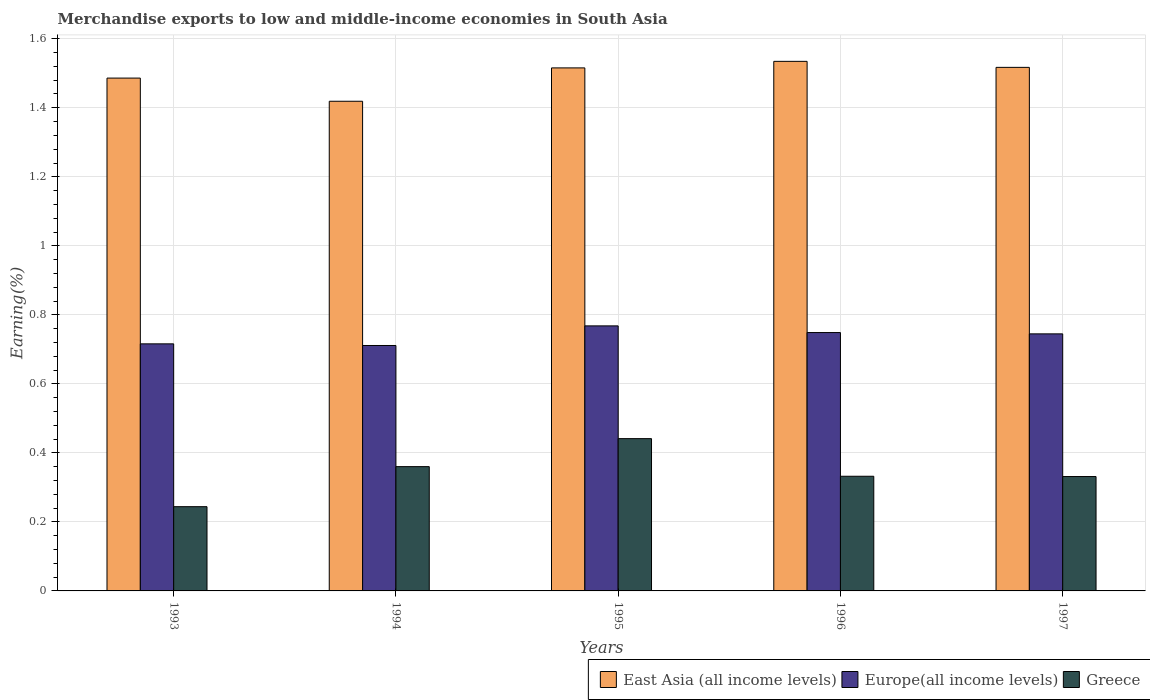How many different coloured bars are there?
Provide a short and direct response. 3. How many groups of bars are there?
Provide a succinct answer. 5. How many bars are there on the 1st tick from the left?
Give a very brief answer. 3. How many bars are there on the 4th tick from the right?
Provide a short and direct response. 3. What is the label of the 1st group of bars from the left?
Offer a terse response. 1993. In how many cases, is the number of bars for a given year not equal to the number of legend labels?
Provide a succinct answer. 0. What is the percentage of amount earned from merchandise exports in Greece in 1996?
Ensure brevity in your answer.  0.33. Across all years, what is the maximum percentage of amount earned from merchandise exports in Europe(all income levels)?
Give a very brief answer. 0.77. Across all years, what is the minimum percentage of amount earned from merchandise exports in Greece?
Give a very brief answer. 0.24. In which year was the percentage of amount earned from merchandise exports in East Asia (all income levels) maximum?
Provide a short and direct response. 1996. What is the total percentage of amount earned from merchandise exports in Greece in the graph?
Ensure brevity in your answer.  1.71. What is the difference between the percentage of amount earned from merchandise exports in Greece in 1995 and that in 1996?
Your answer should be very brief. 0.11. What is the difference between the percentage of amount earned from merchandise exports in Europe(all income levels) in 1993 and the percentage of amount earned from merchandise exports in Greece in 1995?
Provide a succinct answer. 0.27. What is the average percentage of amount earned from merchandise exports in Europe(all income levels) per year?
Ensure brevity in your answer.  0.74. In the year 1994, what is the difference between the percentage of amount earned from merchandise exports in East Asia (all income levels) and percentage of amount earned from merchandise exports in Greece?
Your response must be concise. 1.06. What is the ratio of the percentage of amount earned from merchandise exports in Greece in 1993 to that in 1994?
Provide a short and direct response. 0.68. What is the difference between the highest and the second highest percentage of amount earned from merchandise exports in Europe(all income levels)?
Ensure brevity in your answer.  0.02. What is the difference between the highest and the lowest percentage of amount earned from merchandise exports in Greece?
Make the answer very short. 0.2. In how many years, is the percentage of amount earned from merchandise exports in East Asia (all income levels) greater than the average percentage of amount earned from merchandise exports in East Asia (all income levels) taken over all years?
Provide a short and direct response. 3. What does the 2nd bar from the left in 1994 represents?
Offer a very short reply. Europe(all income levels). What does the 3rd bar from the right in 1994 represents?
Your response must be concise. East Asia (all income levels). Is it the case that in every year, the sum of the percentage of amount earned from merchandise exports in East Asia (all income levels) and percentage of amount earned from merchandise exports in Europe(all income levels) is greater than the percentage of amount earned from merchandise exports in Greece?
Provide a short and direct response. Yes. How many bars are there?
Make the answer very short. 15. How many years are there in the graph?
Your response must be concise. 5. What is the difference between two consecutive major ticks on the Y-axis?
Provide a short and direct response. 0.2. Are the values on the major ticks of Y-axis written in scientific E-notation?
Ensure brevity in your answer.  No. Does the graph contain any zero values?
Offer a terse response. No. Does the graph contain grids?
Provide a succinct answer. Yes. Where does the legend appear in the graph?
Your response must be concise. Bottom right. How many legend labels are there?
Ensure brevity in your answer.  3. How are the legend labels stacked?
Offer a terse response. Horizontal. What is the title of the graph?
Provide a succinct answer. Merchandise exports to low and middle-income economies in South Asia. What is the label or title of the Y-axis?
Offer a very short reply. Earning(%). What is the Earning(%) in East Asia (all income levels) in 1993?
Your answer should be compact. 1.49. What is the Earning(%) in Europe(all income levels) in 1993?
Offer a very short reply. 0.72. What is the Earning(%) of Greece in 1993?
Your answer should be very brief. 0.24. What is the Earning(%) in East Asia (all income levels) in 1994?
Offer a terse response. 1.42. What is the Earning(%) of Europe(all income levels) in 1994?
Ensure brevity in your answer.  0.71. What is the Earning(%) in Greece in 1994?
Offer a terse response. 0.36. What is the Earning(%) of East Asia (all income levels) in 1995?
Offer a very short reply. 1.52. What is the Earning(%) of Europe(all income levels) in 1995?
Your response must be concise. 0.77. What is the Earning(%) in Greece in 1995?
Your answer should be very brief. 0.44. What is the Earning(%) of East Asia (all income levels) in 1996?
Offer a very short reply. 1.53. What is the Earning(%) of Europe(all income levels) in 1996?
Your answer should be compact. 0.75. What is the Earning(%) of Greece in 1996?
Your response must be concise. 0.33. What is the Earning(%) in East Asia (all income levels) in 1997?
Your response must be concise. 1.52. What is the Earning(%) of Europe(all income levels) in 1997?
Make the answer very short. 0.74. What is the Earning(%) in Greece in 1997?
Give a very brief answer. 0.33. Across all years, what is the maximum Earning(%) in East Asia (all income levels)?
Offer a very short reply. 1.53. Across all years, what is the maximum Earning(%) in Europe(all income levels)?
Make the answer very short. 0.77. Across all years, what is the maximum Earning(%) in Greece?
Your answer should be very brief. 0.44. Across all years, what is the minimum Earning(%) of East Asia (all income levels)?
Provide a short and direct response. 1.42. Across all years, what is the minimum Earning(%) in Europe(all income levels)?
Provide a short and direct response. 0.71. Across all years, what is the minimum Earning(%) of Greece?
Give a very brief answer. 0.24. What is the total Earning(%) in East Asia (all income levels) in the graph?
Keep it short and to the point. 7.47. What is the total Earning(%) of Europe(all income levels) in the graph?
Keep it short and to the point. 3.69. What is the total Earning(%) of Greece in the graph?
Your response must be concise. 1.71. What is the difference between the Earning(%) in East Asia (all income levels) in 1993 and that in 1994?
Your response must be concise. 0.07. What is the difference between the Earning(%) of Europe(all income levels) in 1993 and that in 1994?
Offer a terse response. 0. What is the difference between the Earning(%) in Greece in 1993 and that in 1994?
Offer a terse response. -0.12. What is the difference between the Earning(%) of East Asia (all income levels) in 1993 and that in 1995?
Offer a very short reply. -0.03. What is the difference between the Earning(%) in Europe(all income levels) in 1993 and that in 1995?
Your answer should be very brief. -0.05. What is the difference between the Earning(%) in Greece in 1993 and that in 1995?
Keep it short and to the point. -0.2. What is the difference between the Earning(%) in East Asia (all income levels) in 1993 and that in 1996?
Provide a short and direct response. -0.05. What is the difference between the Earning(%) in Europe(all income levels) in 1993 and that in 1996?
Your answer should be compact. -0.03. What is the difference between the Earning(%) in Greece in 1993 and that in 1996?
Give a very brief answer. -0.09. What is the difference between the Earning(%) of East Asia (all income levels) in 1993 and that in 1997?
Make the answer very short. -0.03. What is the difference between the Earning(%) in Europe(all income levels) in 1993 and that in 1997?
Offer a terse response. -0.03. What is the difference between the Earning(%) in Greece in 1993 and that in 1997?
Ensure brevity in your answer.  -0.09. What is the difference between the Earning(%) of East Asia (all income levels) in 1994 and that in 1995?
Your answer should be very brief. -0.1. What is the difference between the Earning(%) of Europe(all income levels) in 1994 and that in 1995?
Ensure brevity in your answer.  -0.06. What is the difference between the Earning(%) of Greece in 1994 and that in 1995?
Your response must be concise. -0.08. What is the difference between the Earning(%) of East Asia (all income levels) in 1994 and that in 1996?
Give a very brief answer. -0.12. What is the difference between the Earning(%) of Europe(all income levels) in 1994 and that in 1996?
Ensure brevity in your answer.  -0.04. What is the difference between the Earning(%) in Greece in 1994 and that in 1996?
Make the answer very short. 0.03. What is the difference between the Earning(%) in East Asia (all income levels) in 1994 and that in 1997?
Your answer should be compact. -0.1. What is the difference between the Earning(%) of Europe(all income levels) in 1994 and that in 1997?
Your answer should be very brief. -0.03. What is the difference between the Earning(%) of Greece in 1994 and that in 1997?
Keep it short and to the point. 0.03. What is the difference between the Earning(%) of East Asia (all income levels) in 1995 and that in 1996?
Ensure brevity in your answer.  -0.02. What is the difference between the Earning(%) of Europe(all income levels) in 1995 and that in 1996?
Ensure brevity in your answer.  0.02. What is the difference between the Earning(%) of Greece in 1995 and that in 1996?
Keep it short and to the point. 0.11. What is the difference between the Earning(%) in East Asia (all income levels) in 1995 and that in 1997?
Give a very brief answer. -0. What is the difference between the Earning(%) in Europe(all income levels) in 1995 and that in 1997?
Make the answer very short. 0.02. What is the difference between the Earning(%) of Greece in 1995 and that in 1997?
Ensure brevity in your answer.  0.11. What is the difference between the Earning(%) of East Asia (all income levels) in 1996 and that in 1997?
Ensure brevity in your answer.  0.02. What is the difference between the Earning(%) of Europe(all income levels) in 1996 and that in 1997?
Give a very brief answer. 0. What is the difference between the Earning(%) of Greece in 1996 and that in 1997?
Ensure brevity in your answer.  0. What is the difference between the Earning(%) of East Asia (all income levels) in 1993 and the Earning(%) of Europe(all income levels) in 1994?
Provide a succinct answer. 0.77. What is the difference between the Earning(%) of East Asia (all income levels) in 1993 and the Earning(%) of Greece in 1994?
Keep it short and to the point. 1.13. What is the difference between the Earning(%) in Europe(all income levels) in 1993 and the Earning(%) in Greece in 1994?
Make the answer very short. 0.36. What is the difference between the Earning(%) of East Asia (all income levels) in 1993 and the Earning(%) of Europe(all income levels) in 1995?
Provide a short and direct response. 0.72. What is the difference between the Earning(%) in East Asia (all income levels) in 1993 and the Earning(%) in Greece in 1995?
Your answer should be very brief. 1.04. What is the difference between the Earning(%) in Europe(all income levels) in 1993 and the Earning(%) in Greece in 1995?
Your answer should be very brief. 0.27. What is the difference between the Earning(%) of East Asia (all income levels) in 1993 and the Earning(%) of Europe(all income levels) in 1996?
Offer a very short reply. 0.74. What is the difference between the Earning(%) in East Asia (all income levels) in 1993 and the Earning(%) in Greece in 1996?
Your response must be concise. 1.15. What is the difference between the Earning(%) in Europe(all income levels) in 1993 and the Earning(%) in Greece in 1996?
Your response must be concise. 0.38. What is the difference between the Earning(%) of East Asia (all income levels) in 1993 and the Earning(%) of Europe(all income levels) in 1997?
Your response must be concise. 0.74. What is the difference between the Earning(%) of East Asia (all income levels) in 1993 and the Earning(%) of Greece in 1997?
Keep it short and to the point. 1.15. What is the difference between the Earning(%) of Europe(all income levels) in 1993 and the Earning(%) of Greece in 1997?
Your answer should be very brief. 0.38. What is the difference between the Earning(%) in East Asia (all income levels) in 1994 and the Earning(%) in Europe(all income levels) in 1995?
Offer a very short reply. 0.65. What is the difference between the Earning(%) of East Asia (all income levels) in 1994 and the Earning(%) of Greece in 1995?
Offer a very short reply. 0.98. What is the difference between the Earning(%) in Europe(all income levels) in 1994 and the Earning(%) in Greece in 1995?
Ensure brevity in your answer.  0.27. What is the difference between the Earning(%) in East Asia (all income levels) in 1994 and the Earning(%) in Europe(all income levels) in 1996?
Provide a short and direct response. 0.67. What is the difference between the Earning(%) in East Asia (all income levels) in 1994 and the Earning(%) in Greece in 1996?
Offer a very short reply. 1.09. What is the difference between the Earning(%) of Europe(all income levels) in 1994 and the Earning(%) of Greece in 1996?
Your answer should be very brief. 0.38. What is the difference between the Earning(%) of East Asia (all income levels) in 1994 and the Earning(%) of Europe(all income levels) in 1997?
Keep it short and to the point. 0.67. What is the difference between the Earning(%) in East Asia (all income levels) in 1994 and the Earning(%) in Greece in 1997?
Your response must be concise. 1.09. What is the difference between the Earning(%) in Europe(all income levels) in 1994 and the Earning(%) in Greece in 1997?
Ensure brevity in your answer.  0.38. What is the difference between the Earning(%) of East Asia (all income levels) in 1995 and the Earning(%) of Europe(all income levels) in 1996?
Your response must be concise. 0.77. What is the difference between the Earning(%) in East Asia (all income levels) in 1995 and the Earning(%) in Greece in 1996?
Provide a succinct answer. 1.18. What is the difference between the Earning(%) of Europe(all income levels) in 1995 and the Earning(%) of Greece in 1996?
Your response must be concise. 0.44. What is the difference between the Earning(%) of East Asia (all income levels) in 1995 and the Earning(%) of Europe(all income levels) in 1997?
Provide a succinct answer. 0.77. What is the difference between the Earning(%) in East Asia (all income levels) in 1995 and the Earning(%) in Greece in 1997?
Give a very brief answer. 1.18. What is the difference between the Earning(%) in Europe(all income levels) in 1995 and the Earning(%) in Greece in 1997?
Offer a terse response. 0.44. What is the difference between the Earning(%) of East Asia (all income levels) in 1996 and the Earning(%) of Europe(all income levels) in 1997?
Ensure brevity in your answer.  0.79. What is the difference between the Earning(%) of East Asia (all income levels) in 1996 and the Earning(%) of Greece in 1997?
Ensure brevity in your answer.  1.2. What is the difference between the Earning(%) of Europe(all income levels) in 1996 and the Earning(%) of Greece in 1997?
Provide a short and direct response. 0.42. What is the average Earning(%) of East Asia (all income levels) per year?
Your response must be concise. 1.49. What is the average Earning(%) of Europe(all income levels) per year?
Provide a succinct answer. 0.74. What is the average Earning(%) of Greece per year?
Your response must be concise. 0.34. In the year 1993, what is the difference between the Earning(%) of East Asia (all income levels) and Earning(%) of Europe(all income levels)?
Your answer should be compact. 0.77. In the year 1993, what is the difference between the Earning(%) in East Asia (all income levels) and Earning(%) in Greece?
Make the answer very short. 1.24. In the year 1993, what is the difference between the Earning(%) of Europe(all income levels) and Earning(%) of Greece?
Offer a very short reply. 0.47. In the year 1994, what is the difference between the Earning(%) of East Asia (all income levels) and Earning(%) of Europe(all income levels)?
Ensure brevity in your answer.  0.71. In the year 1994, what is the difference between the Earning(%) of East Asia (all income levels) and Earning(%) of Greece?
Ensure brevity in your answer.  1.06. In the year 1994, what is the difference between the Earning(%) in Europe(all income levels) and Earning(%) in Greece?
Your answer should be compact. 0.35. In the year 1995, what is the difference between the Earning(%) of East Asia (all income levels) and Earning(%) of Europe(all income levels)?
Provide a short and direct response. 0.75. In the year 1995, what is the difference between the Earning(%) of East Asia (all income levels) and Earning(%) of Greece?
Your answer should be compact. 1.07. In the year 1995, what is the difference between the Earning(%) of Europe(all income levels) and Earning(%) of Greece?
Offer a very short reply. 0.33. In the year 1996, what is the difference between the Earning(%) in East Asia (all income levels) and Earning(%) in Europe(all income levels)?
Your response must be concise. 0.79. In the year 1996, what is the difference between the Earning(%) of East Asia (all income levels) and Earning(%) of Greece?
Provide a succinct answer. 1.2. In the year 1996, what is the difference between the Earning(%) of Europe(all income levels) and Earning(%) of Greece?
Make the answer very short. 0.42. In the year 1997, what is the difference between the Earning(%) in East Asia (all income levels) and Earning(%) in Europe(all income levels)?
Keep it short and to the point. 0.77. In the year 1997, what is the difference between the Earning(%) of East Asia (all income levels) and Earning(%) of Greece?
Keep it short and to the point. 1.19. In the year 1997, what is the difference between the Earning(%) of Europe(all income levels) and Earning(%) of Greece?
Provide a short and direct response. 0.41. What is the ratio of the Earning(%) in East Asia (all income levels) in 1993 to that in 1994?
Give a very brief answer. 1.05. What is the ratio of the Earning(%) in Greece in 1993 to that in 1994?
Your answer should be very brief. 0.68. What is the ratio of the Earning(%) of East Asia (all income levels) in 1993 to that in 1995?
Provide a short and direct response. 0.98. What is the ratio of the Earning(%) in Europe(all income levels) in 1993 to that in 1995?
Your answer should be compact. 0.93. What is the ratio of the Earning(%) in Greece in 1993 to that in 1995?
Make the answer very short. 0.55. What is the ratio of the Earning(%) in East Asia (all income levels) in 1993 to that in 1996?
Offer a terse response. 0.97. What is the ratio of the Earning(%) of Europe(all income levels) in 1993 to that in 1996?
Your response must be concise. 0.96. What is the ratio of the Earning(%) in Greece in 1993 to that in 1996?
Provide a succinct answer. 0.73. What is the ratio of the Earning(%) in East Asia (all income levels) in 1993 to that in 1997?
Your answer should be compact. 0.98. What is the ratio of the Earning(%) of Europe(all income levels) in 1993 to that in 1997?
Give a very brief answer. 0.96. What is the ratio of the Earning(%) in Greece in 1993 to that in 1997?
Provide a short and direct response. 0.74. What is the ratio of the Earning(%) of East Asia (all income levels) in 1994 to that in 1995?
Your answer should be compact. 0.94. What is the ratio of the Earning(%) in Europe(all income levels) in 1994 to that in 1995?
Offer a terse response. 0.93. What is the ratio of the Earning(%) in Greece in 1994 to that in 1995?
Ensure brevity in your answer.  0.82. What is the ratio of the Earning(%) in East Asia (all income levels) in 1994 to that in 1996?
Keep it short and to the point. 0.92. What is the ratio of the Earning(%) in Europe(all income levels) in 1994 to that in 1996?
Offer a very short reply. 0.95. What is the ratio of the Earning(%) in Greece in 1994 to that in 1996?
Provide a succinct answer. 1.08. What is the ratio of the Earning(%) in East Asia (all income levels) in 1994 to that in 1997?
Offer a terse response. 0.94. What is the ratio of the Earning(%) in Europe(all income levels) in 1994 to that in 1997?
Provide a short and direct response. 0.95. What is the ratio of the Earning(%) in Greece in 1994 to that in 1997?
Keep it short and to the point. 1.09. What is the ratio of the Earning(%) in East Asia (all income levels) in 1995 to that in 1996?
Offer a very short reply. 0.99. What is the ratio of the Earning(%) of Europe(all income levels) in 1995 to that in 1996?
Offer a terse response. 1.03. What is the ratio of the Earning(%) in Greece in 1995 to that in 1996?
Provide a short and direct response. 1.33. What is the ratio of the Earning(%) in East Asia (all income levels) in 1995 to that in 1997?
Make the answer very short. 1. What is the ratio of the Earning(%) of Europe(all income levels) in 1995 to that in 1997?
Keep it short and to the point. 1.03. What is the ratio of the Earning(%) in Greece in 1995 to that in 1997?
Your answer should be compact. 1.33. What is the ratio of the Earning(%) of East Asia (all income levels) in 1996 to that in 1997?
Your answer should be compact. 1.01. What is the ratio of the Earning(%) in Europe(all income levels) in 1996 to that in 1997?
Make the answer very short. 1.01. What is the ratio of the Earning(%) in Greece in 1996 to that in 1997?
Provide a succinct answer. 1. What is the difference between the highest and the second highest Earning(%) in East Asia (all income levels)?
Your answer should be very brief. 0.02. What is the difference between the highest and the second highest Earning(%) in Europe(all income levels)?
Ensure brevity in your answer.  0.02. What is the difference between the highest and the second highest Earning(%) of Greece?
Give a very brief answer. 0.08. What is the difference between the highest and the lowest Earning(%) in East Asia (all income levels)?
Offer a terse response. 0.12. What is the difference between the highest and the lowest Earning(%) of Europe(all income levels)?
Your answer should be compact. 0.06. What is the difference between the highest and the lowest Earning(%) in Greece?
Your answer should be compact. 0.2. 